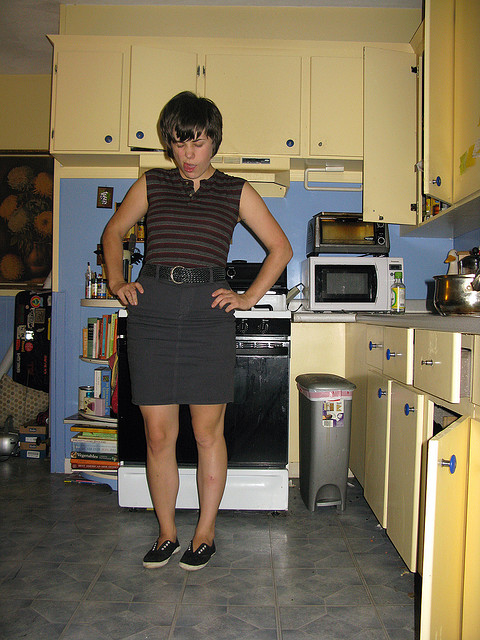How many ovens are there? There are two ovens visible in the kitchen; one is the main oven located within the stove, and the second is a microwave oven mounted above the stove. Both are commonly used for a variety of cooking methods. 